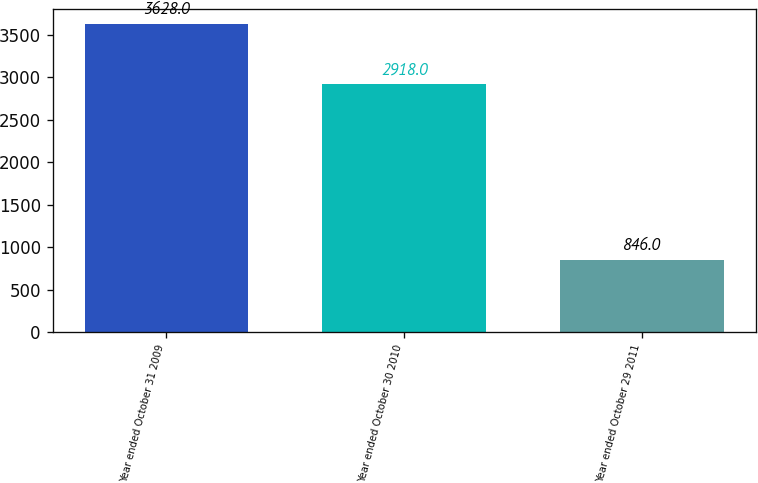Convert chart to OTSL. <chart><loc_0><loc_0><loc_500><loc_500><bar_chart><fcel>Year ended October 31 2009<fcel>Year ended October 30 2010<fcel>Year ended October 29 2011<nl><fcel>3628<fcel>2918<fcel>846<nl></chart> 